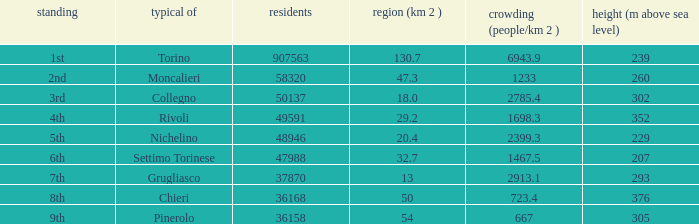How many altitudes does the common with an area of 130.7 km^2 have? 1.0. 